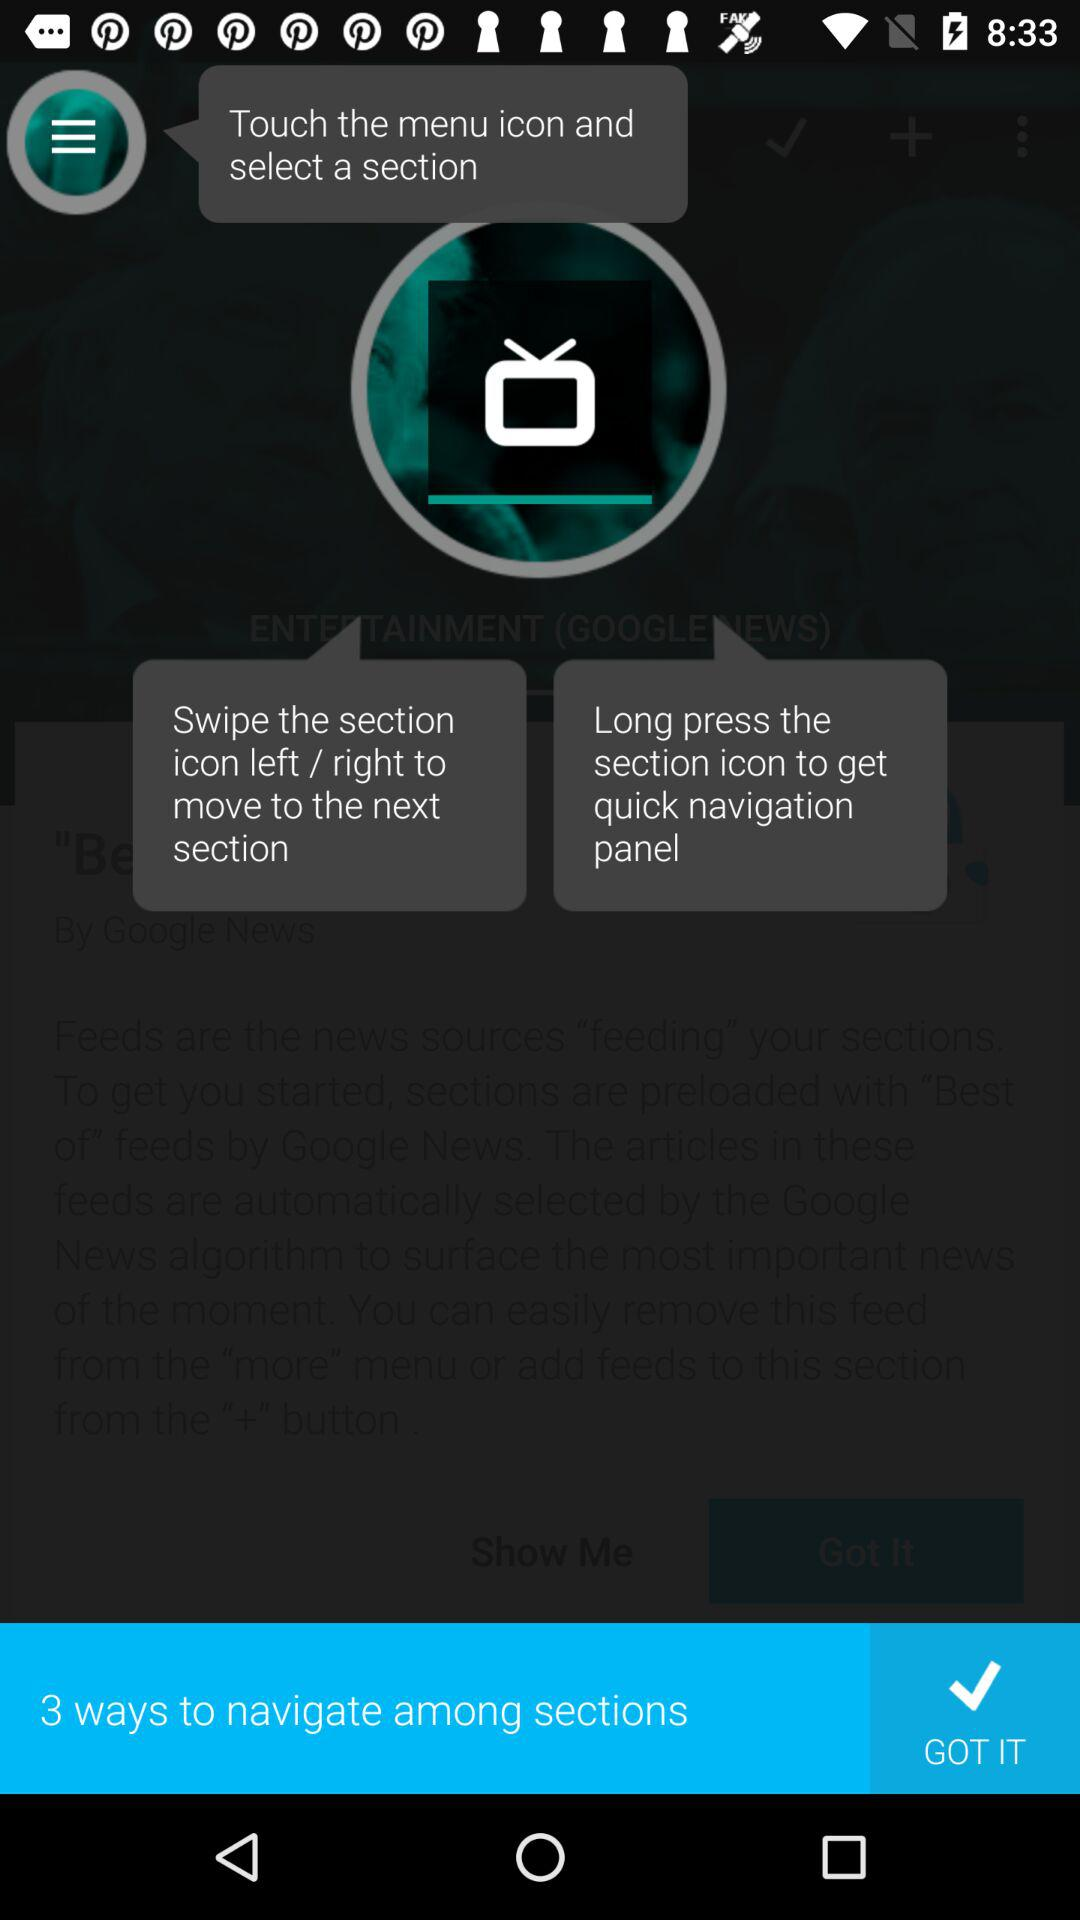How many text elements are there that show how to navigate among sections?
Answer the question using a single word or phrase. 3 